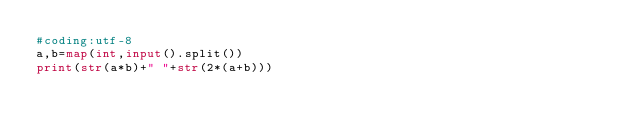Convert code to text. <code><loc_0><loc_0><loc_500><loc_500><_Python_>#coding:utf-8
a,b=map(int,input().split())
print(str(a*b)+" "+str(2*(a+b)))</code> 